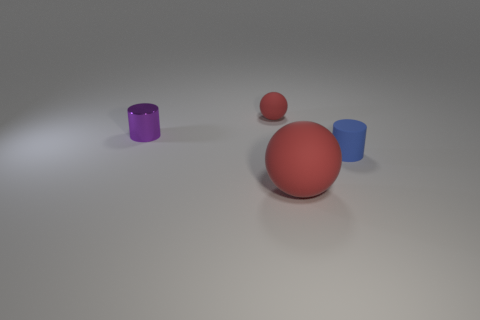The tiny matte object to the right of the big thing has what shape? cylinder 